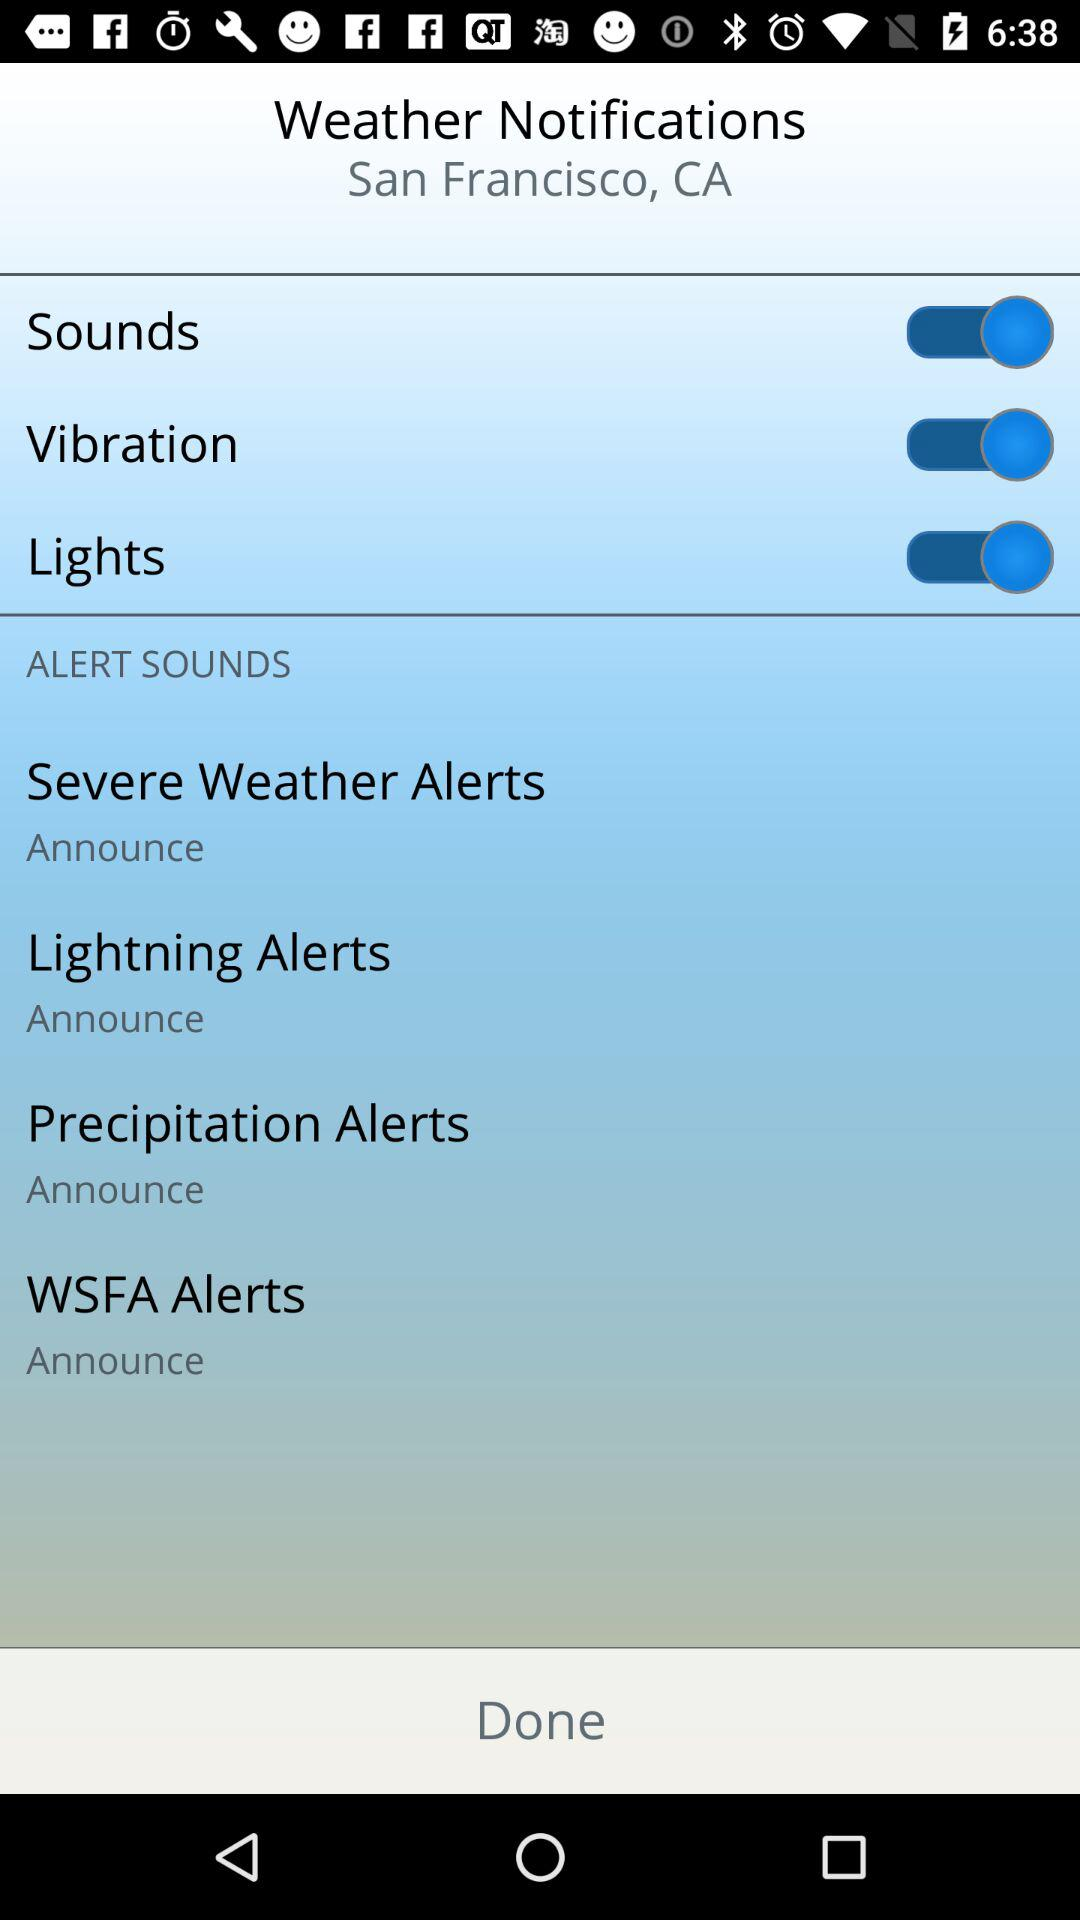What is the setting for the "Severe Weather Alerts" notification? The setting for the "Severe Weather Alerts" notification is "Announce". 